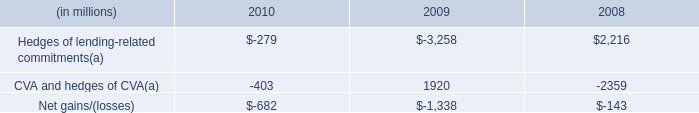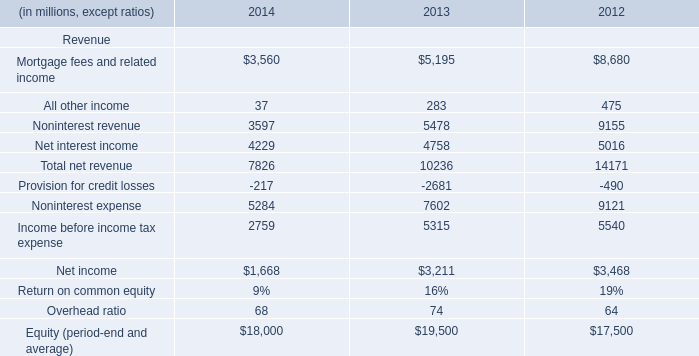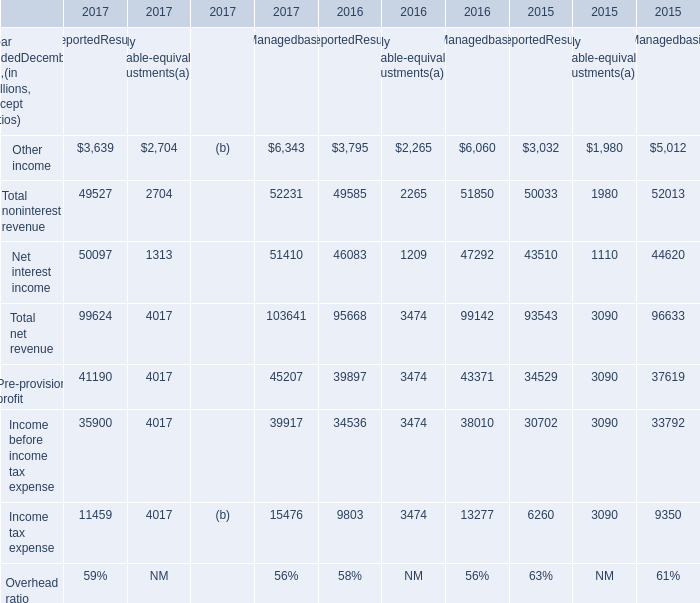IIn the section with largest amount of Other income, what's the sum of Net interest income and Total net revenue in 2017? (in million) 
Computations: (51410 + 103641)
Answer: 155051.0. 